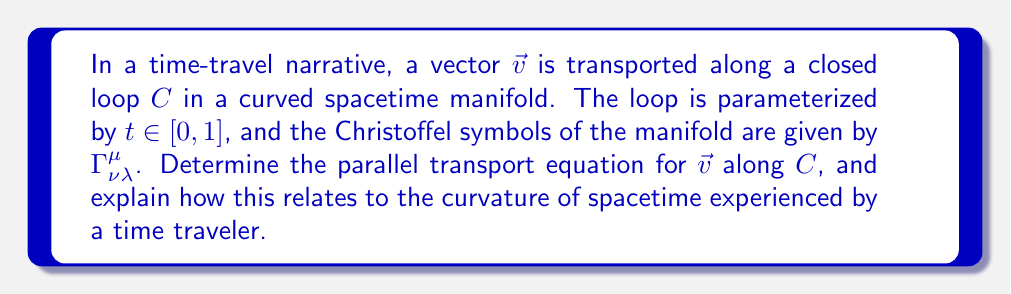Show me your answer to this math problem. To solve this problem, we'll follow these steps:

1) The parallel transport equation in a curved spacetime is given by:

   $$\frac{D v^\mu}{dt} = \frac{dv^\mu}{dt} + \Gamma^\mu_{\nu\lambda} v^\nu \frac{dx^\lambda}{dt} = 0$$

   where $v^\mu$ are the components of the vector $\vec{v}$, and $x^\lambda(t)$ describes the path $C$.

2) This equation ensures that the vector remains parallel to itself as it's transported along the curve.

3) For a closed loop, $x^\lambda(0) = x^\lambda(1)$. However, $v^\mu(0)$ may not equal $v^\mu(1)$ due to the curvature of spacetime.

4) The difference between $v^\mu(0)$ and $v^\mu(1)$ is related to the holonomy of the connection, which measures the curvature of the manifold.

5) For an infinitesimal loop, this difference is given by the Riemann curvature tensor:

   $$\delta v^\mu = R^\mu_{\nu\lambda\rho} v^\nu dx^\lambda dx^\rho$$

6) For a time traveler, this means that objects carried through a closed timelike curve may return slightly altered due to spacetime curvature, potentially creating paradoxes or altered timelines.

7) The parallel transport equation thus provides a mathematical framework for understanding how objects (or information) might be affected when moved through curved spacetime in a time travel scenario.
Answer: $\frac{D v^\mu}{dt} = \frac{dv^\mu}{dt} + \Gamma^\mu_{\nu\lambda} v^\nu \frac{dx^\lambda}{dt} = 0$ 